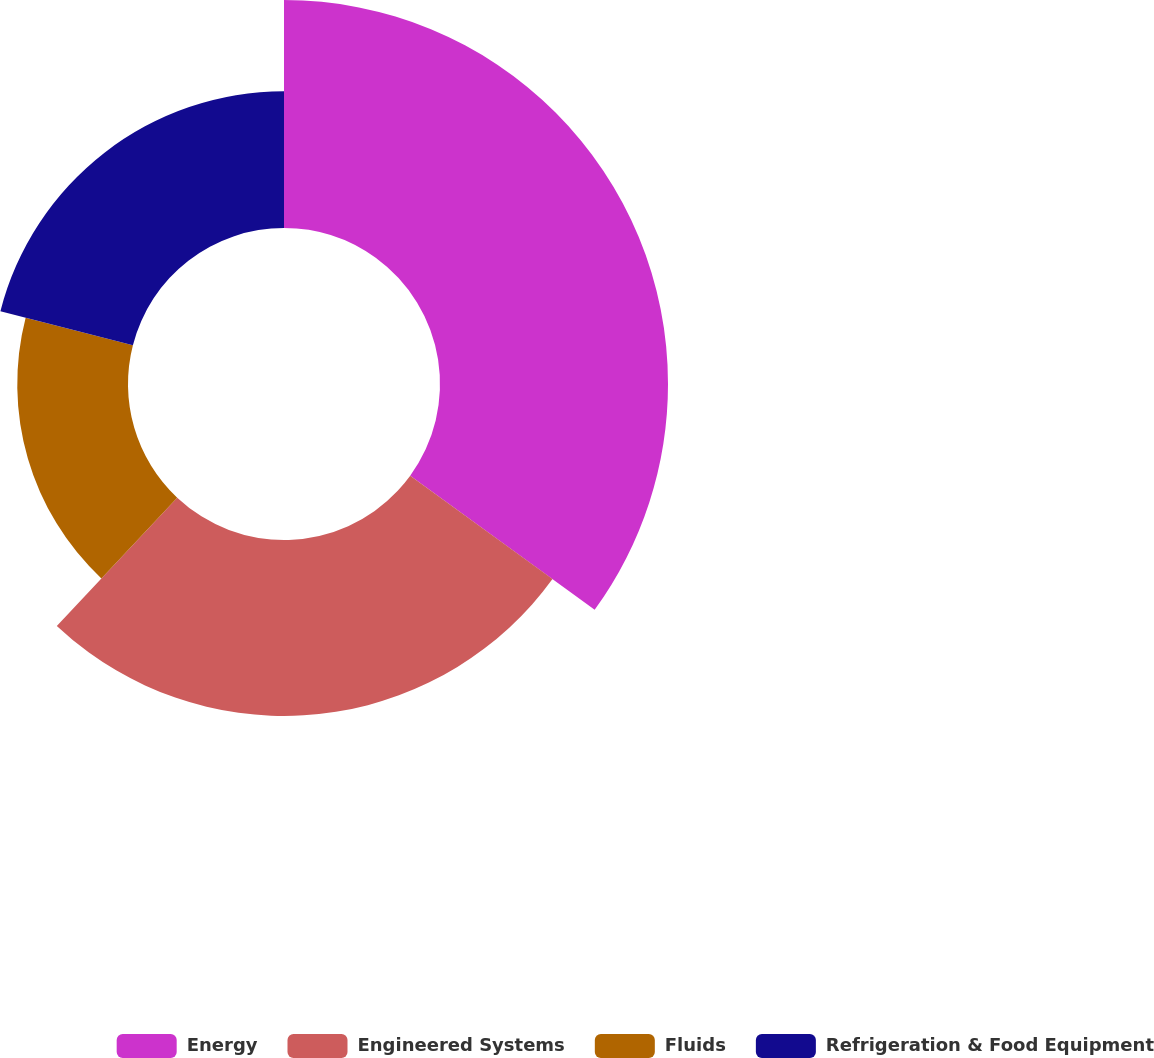<chart> <loc_0><loc_0><loc_500><loc_500><pie_chart><fcel>Energy<fcel>Engineered Systems<fcel>Fluids<fcel>Refrigeration & Food Equipment<nl><fcel>35.0%<fcel>27.0%<fcel>17.0%<fcel>21.0%<nl></chart> 